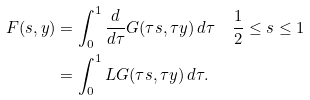<formula> <loc_0><loc_0><loc_500><loc_500>F ( s , y ) & = \int _ { 0 } ^ { 1 } \frac { d } { d \tau } G ( \tau s , \tau y ) \, d \tau \quad \frac { 1 } { 2 } \leq s \leq 1 \\ & = \int _ { 0 } ^ { 1 } L G ( \tau s , \tau y ) \, d \tau .</formula> 